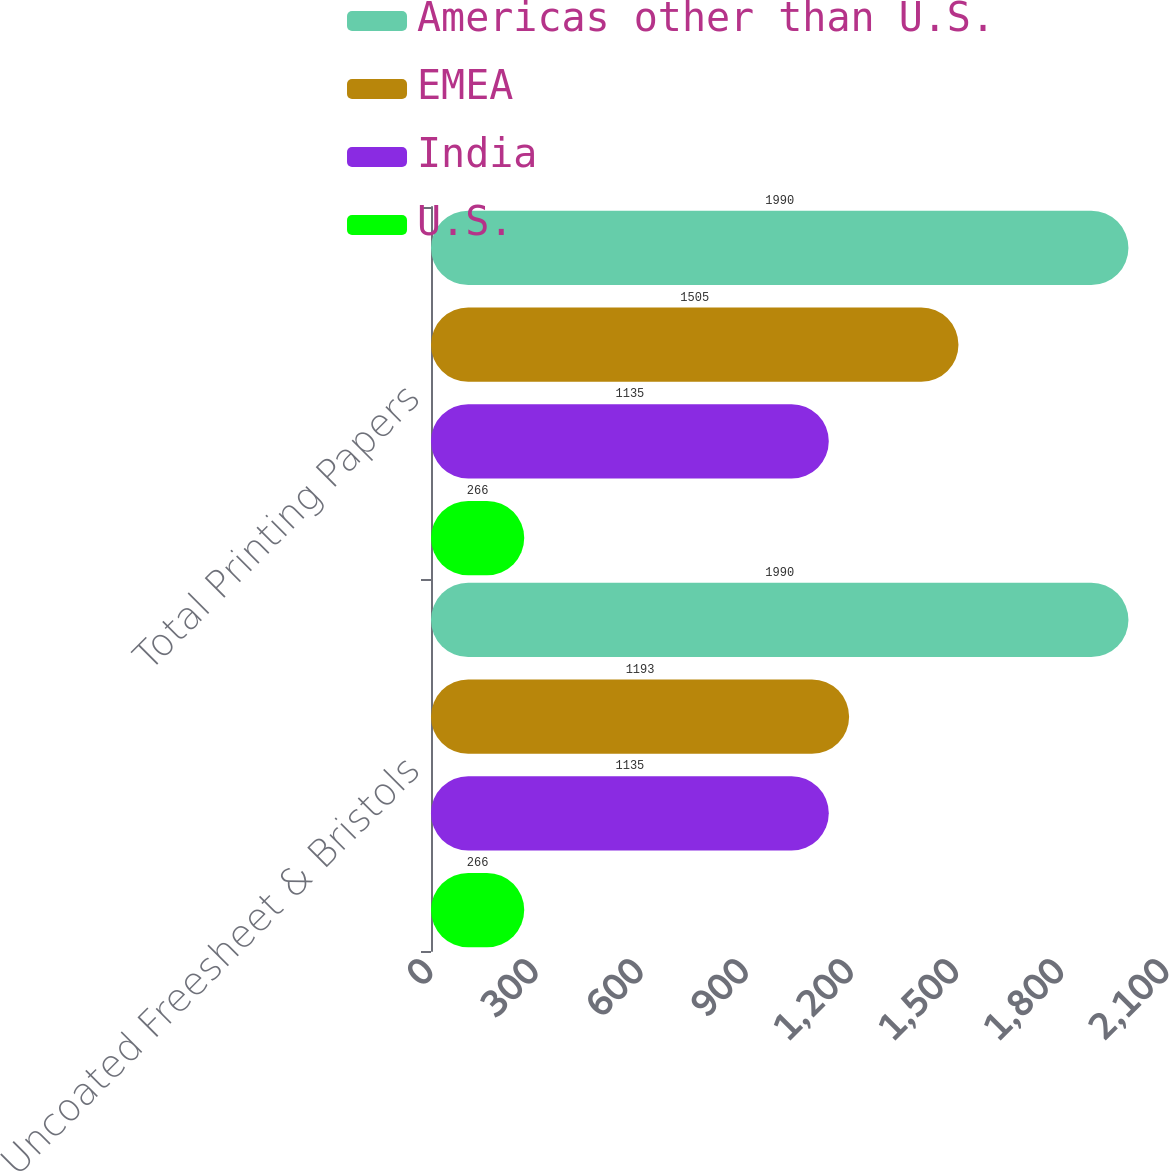Convert chart. <chart><loc_0><loc_0><loc_500><loc_500><stacked_bar_chart><ecel><fcel>Uncoated Freesheet & Bristols<fcel>Total Printing Papers<nl><fcel>Americas other than U.S.<fcel>1990<fcel>1990<nl><fcel>EMEA<fcel>1193<fcel>1505<nl><fcel>India<fcel>1135<fcel>1135<nl><fcel>U.S.<fcel>266<fcel>266<nl></chart> 